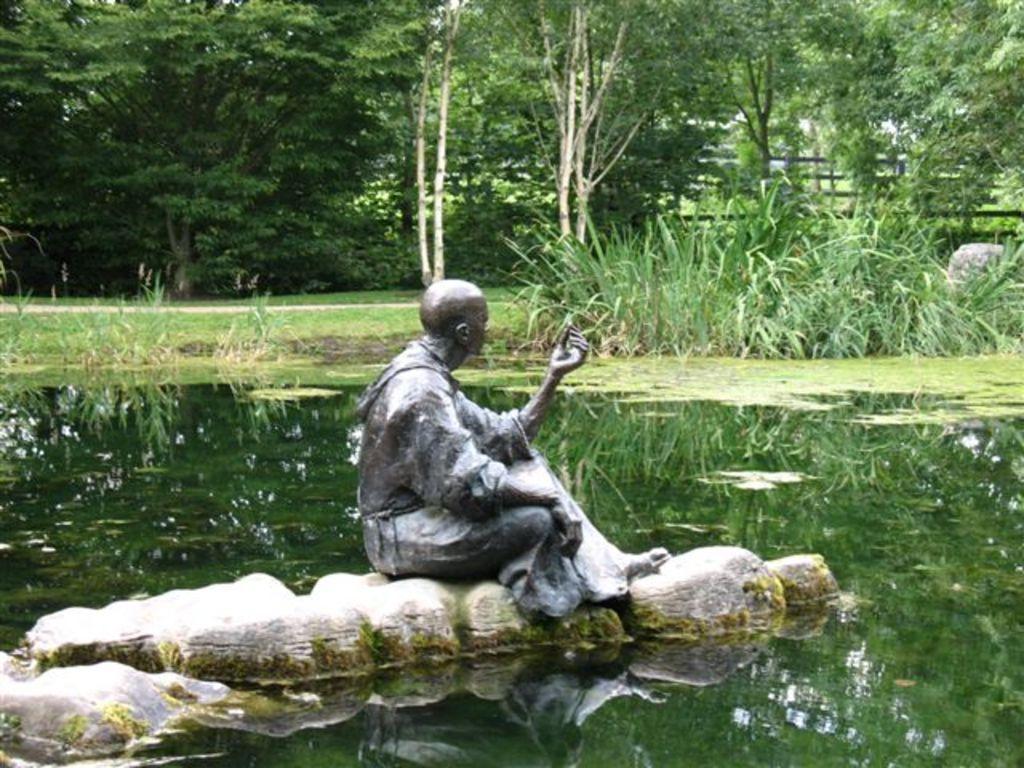Describe this image in one or two sentences. In this image I can see statue of a person. In the background I can see plants, water and trees. 